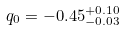<formula> <loc_0><loc_0><loc_500><loc_500>q _ { 0 } = - 0 . 4 5 ^ { + 0 . 1 0 } _ { - 0 . 0 3 }</formula> 